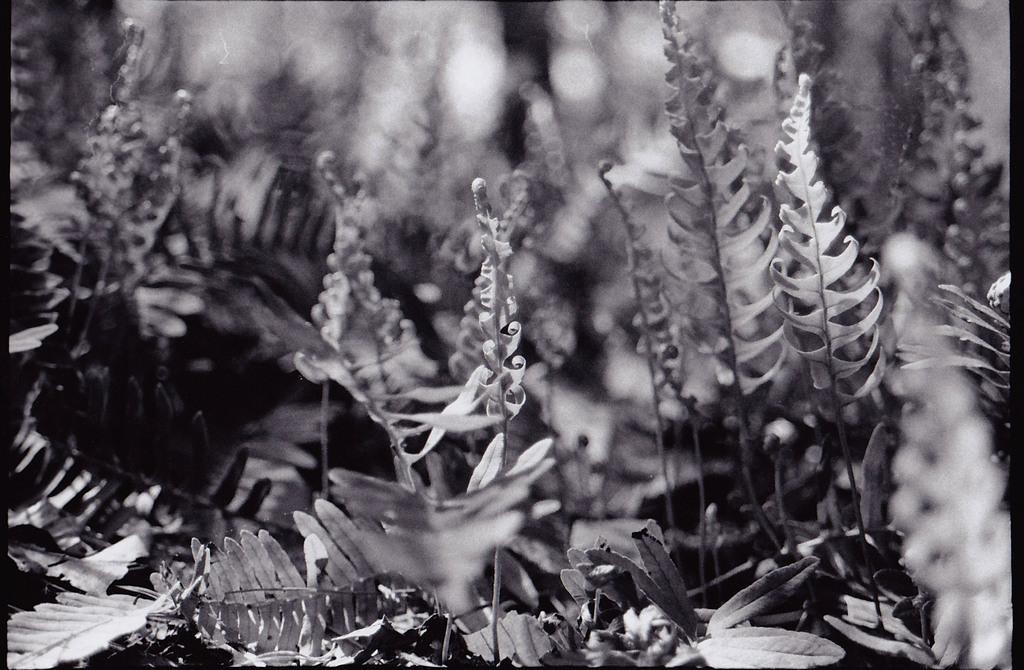Please provide a concise description of this image. This is a black and white image. We can see some plants and the blurred background. 